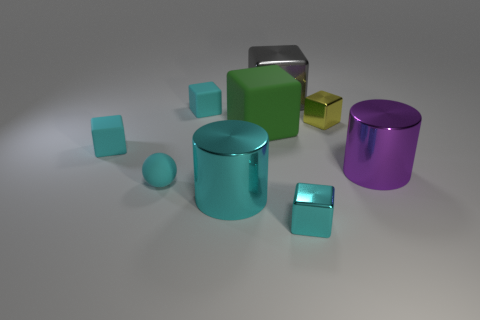Subtract all big green blocks. How many blocks are left? 5 Subtract all purple spheres. How many cyan cubes are left? 3 Subtract all green cubes. How many cubes are left? 5 Subtract all cylinders. How many objects are left? 7 Add 8 small green metallic cylinders. How many small green metallic cylinders exist? 8 Subtract 0 green cylinders. How many objects are left? 9 Subtract all blue cylinders. Subtract all cyan spheres. How many cylinders are left? 2 Subtract all large gray shiny cubes. Subtract all cyan matte spheres. How many objects are left? 7 Add 5 yellow objects. How many yellow objects are left? 6 